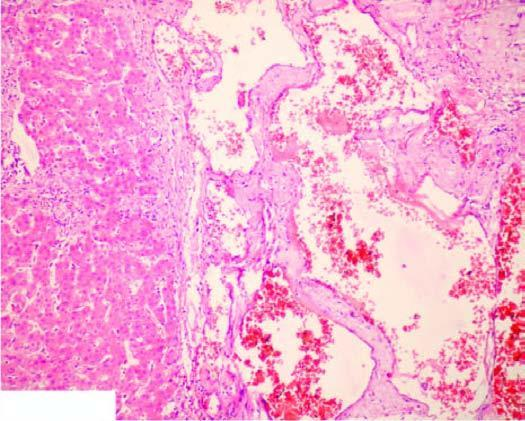what is scanty connective tissue stroma seen between?
Answer the question using a single word or phrase. The cavernous spaces 